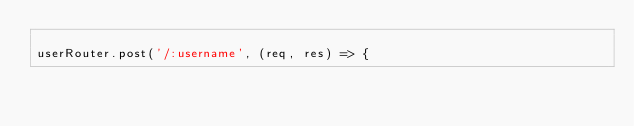<code> <loc_0><loc_0><loc_500><loc_500><_JavaScript_>
userRouter.post('/:username', (req, res) => {</code> 